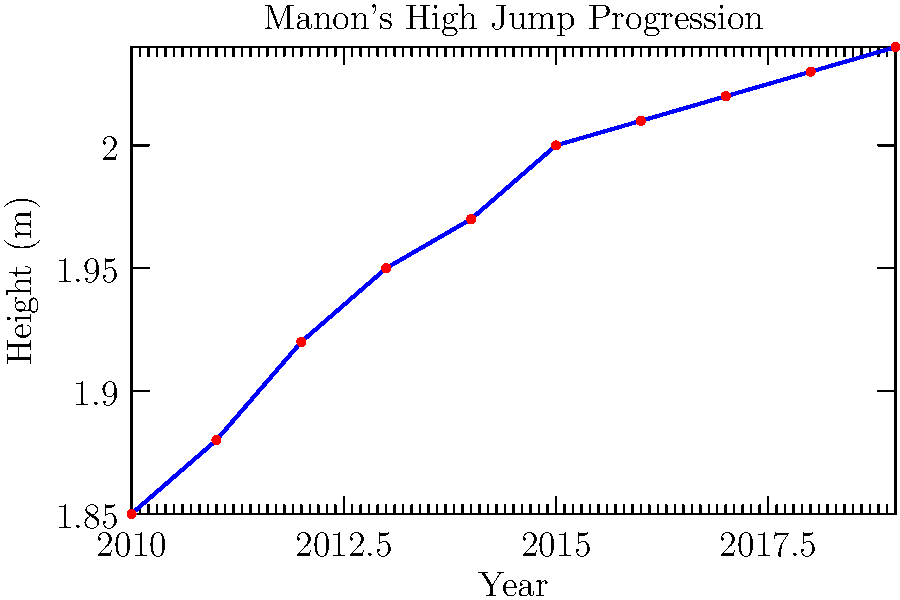Based on the graph showing Manon's high jump progression, what was her largest single-year improvement in height, and in which year did this occur? To find the largest single-year improvement, we need to calculate the difference in height between consecutive years and identify the maximum:

1. 2010 to 2011: $1.88 - 1.85 = 0.03$ m
2. 2011 to 2012: $1.92 - 1.88 = 0.04$ m
3. 2012 to 2013: $1.95 - 1.92 = 0.03$ m
4. 2013 to 2014: $1.97 - 1.95 = 0.02$ m
5. 2014 to 2015: $2.00 - 1.97 = 0.03$ m
6. 2015 to 2016: $2.01 - 2.00 = 0.01$ m
7. 2016 to 2017: $2.02 - 2.01 = 0.01$ m
8. 2017 to 2018: $2.03 - 2.02 = 0.01$ m
9. 2018 to 2019: $2.04 - 2.03 = 0.01$ m

The largest improvement is 0.04 m, which occurred from 2011 to 2012.
Answer: 0.04 m in 2012 